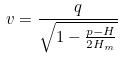Convert formula to latex. <formula><loc_0><loc_0><loc_500><loc_500>v = \frac { q } { \sqrt { 1 - \frac { p - H } { 2 H _ { m } } } }</formula> 